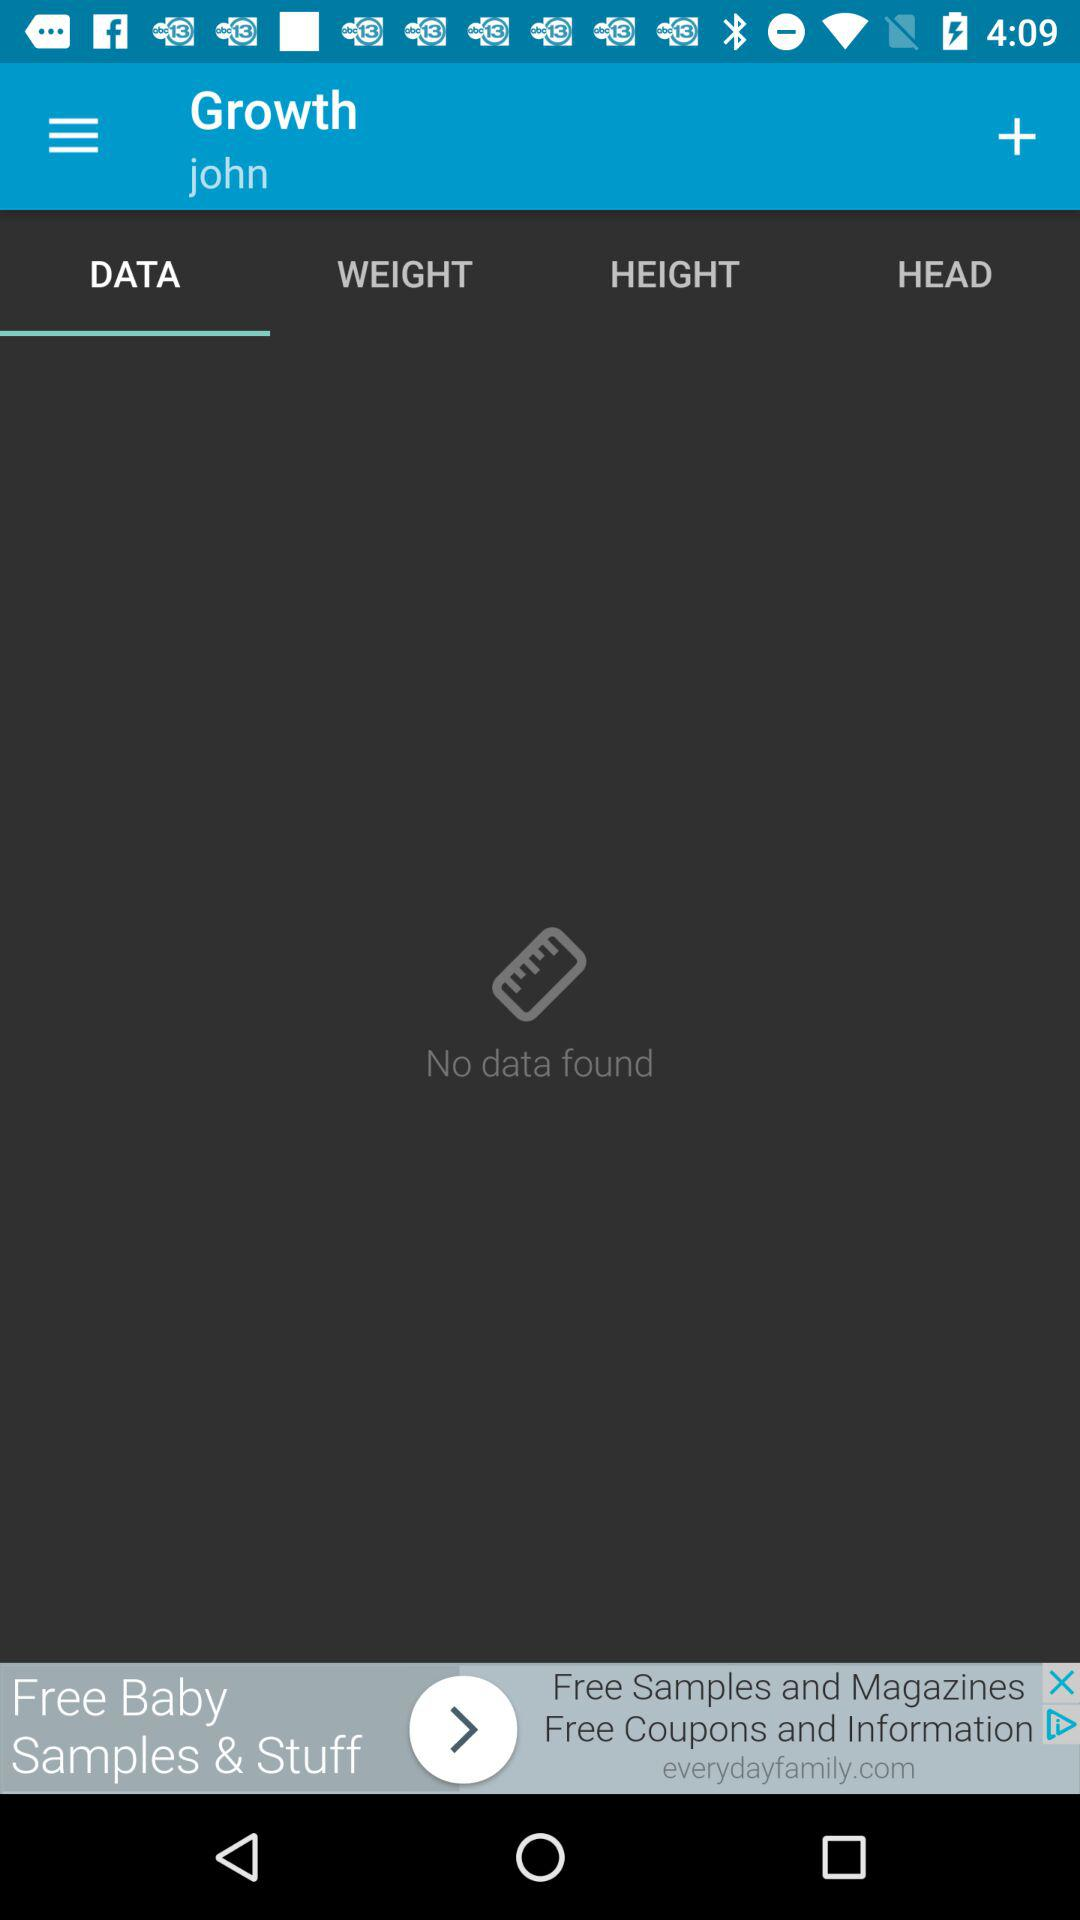Which tab am I using? The tab you are using is "DATA". 